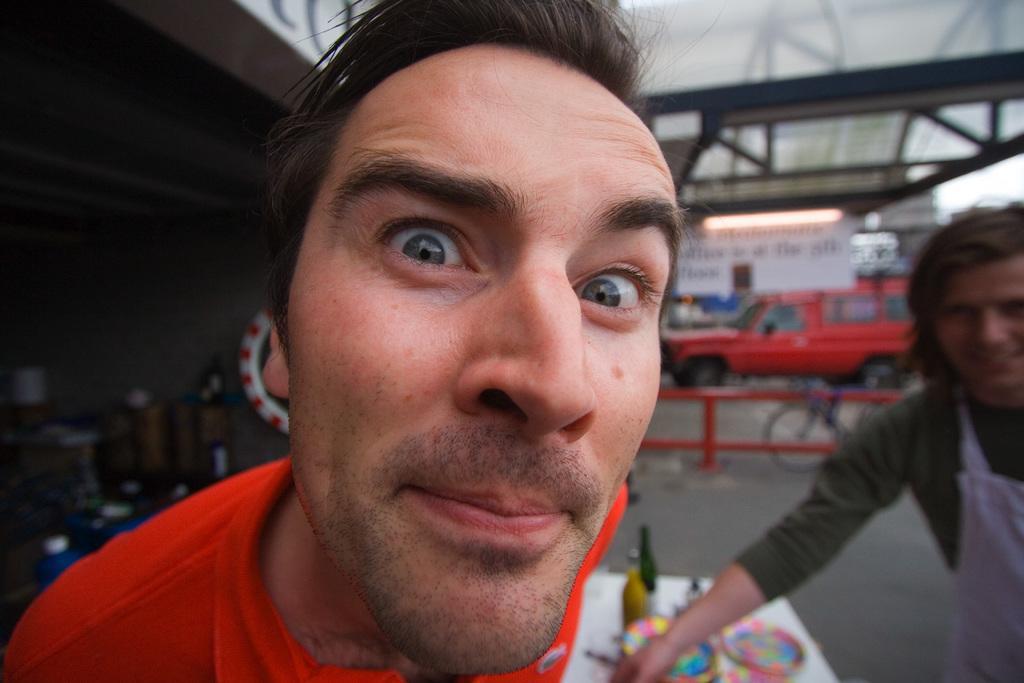Describe this image in one or two sentences. In this image, we can see a man wearing a red t-shirt and smiling. The background of the image is blur. On the right side of the image, we can see another person, bicycle, vehicle, board, light, rods and few objects. On the left side of the image, there are few objects and wall. 